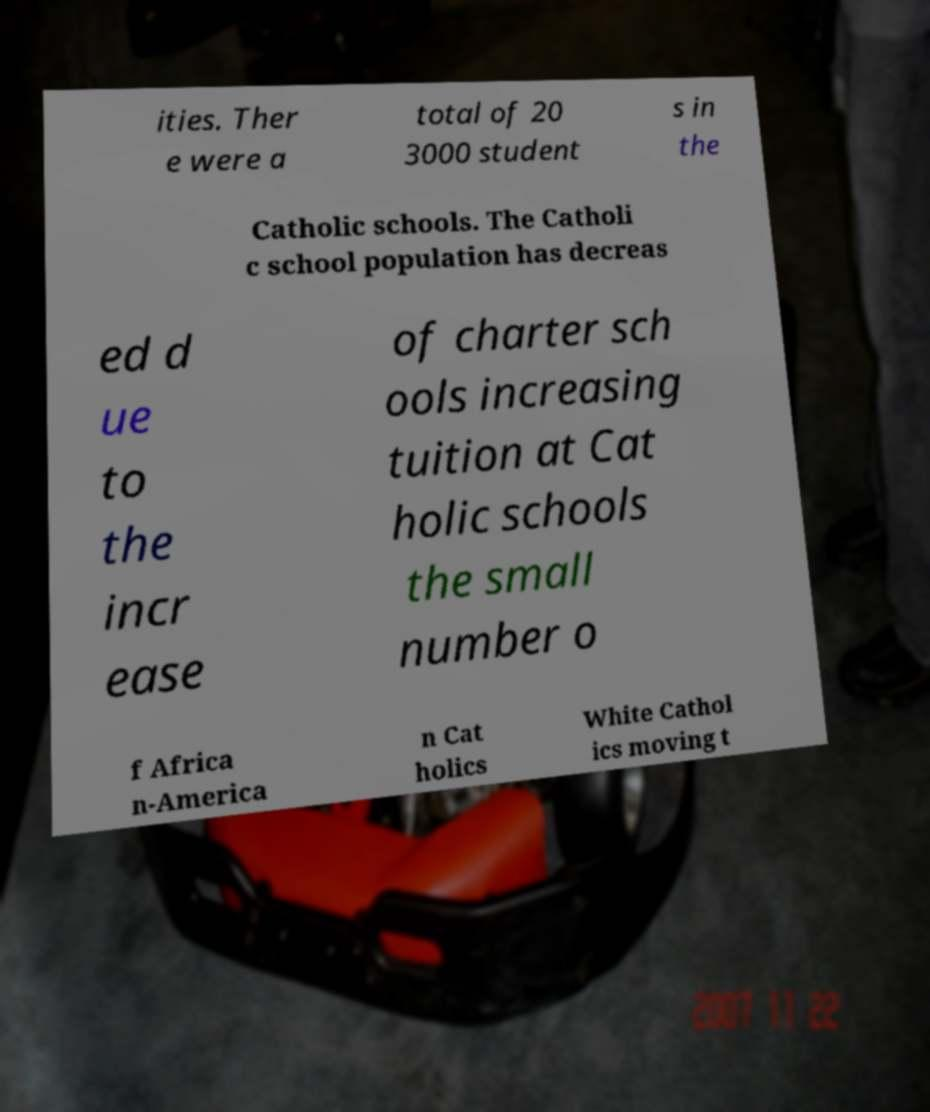Can you accurately transcribe the text from the provided image for me? ities. Ther e were a total of 20 3000 student s in the Catholic schools. The Catholi c school population has decreas ed d ue to the incr ease of charter sch ools increasing tuition at Cat holic schools the small number o f Africa n-America n Cat holics White Cathol ics moving t 